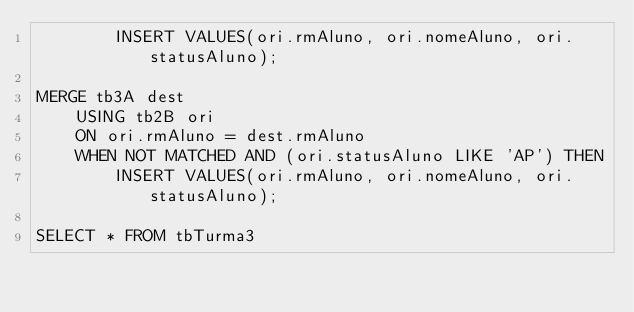Convert code to text. <code><loc_0><loc_0><loc_500><loc_500><_SQL_>        INSERT VALUES(ori.rmAluno, ori.nomeAluno, ori.statusAluno);

MERGE tb3A dest
    USING tb2B ori
    ON ori.rmAluno = dest.rmAluno
    WHEN NOT MATCHED AND (ori.statusAluno LIKE 'AP') THEN
        INSERT VALUES(ori.rmAluno, ori.nomeAluno, ori.statusAluno);
    
SELECT * FROM tbTurma3</code> 